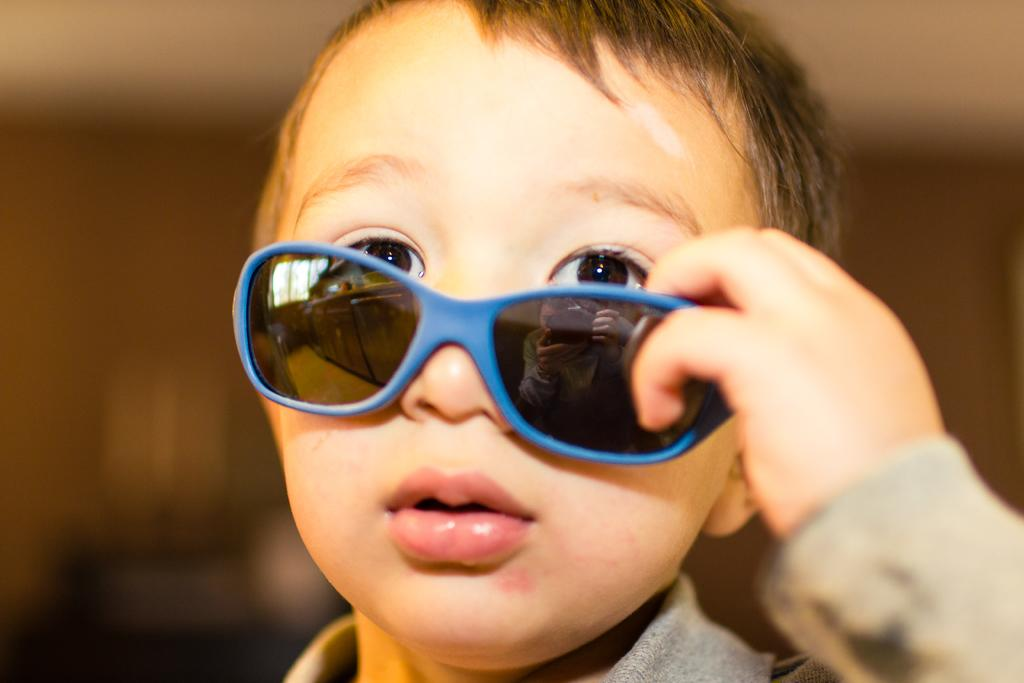What is the main subject of the picture? The main subject of the picture is a boy. What is the boy wearing in the picture? The boy is wearing goggles in the picture. Can you describe the background of the image? The background of the image is blurry. What type of crime is being committed in the picture? There is no crime being committed in the picture; it features a boy wearing goggles with a blurry background. Is there a party happening in the picture? There is no indication of a party in the picture; it only shows a boy wearing goggles with a blurry background. 